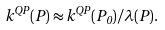<formula> <loc_0><loc_0><loc_500><loc_500>k ^ { Q P } ( P ) \approx k ^ { Q P } ( P _ { 0 } ) / \lambda ( { P } ) .</formula> 